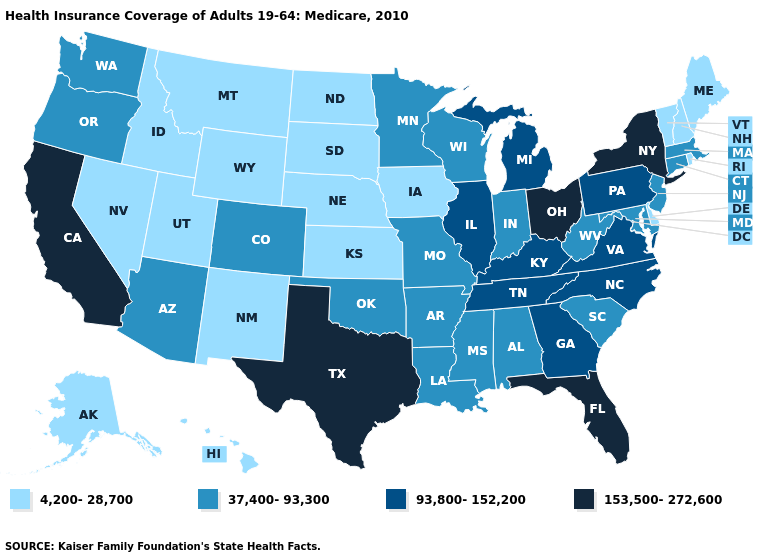Does the map have missing data?
Write a very short answer. No. Does New York have a higher value than Florida?
Keep it brief. No. Does the map have missing data?
Keep it brief. No. What is the value of Arkansas?
Give a very brief answer. 37,400-93,300. What is the highest value in the USA?
Short answer required. 153,500-272,600. Does Idaho have the same value as Texas?
Concise answer only. No. What is the value of New Jersey?
Quick response, please. 37,400-93,300. Is the legend a continuous bar?
Keep it brief. No. What is the highest value in the MidWest ?
Keep it brief. 153,500-272,600. Does Florida have the same value as Ohio?
Quick response, please. Yes. Name the states that have a value in the range 153,500-272,600?
Short answer required. California, Florida, New York, Ohio, Texas. Is the legend a continuous bar?
Answer briefly. No. Does Washington have the same value as Alabama?
Answer briefly. Yes. Does South Carolina have a lower value than Ohio?
Be succinct. Yes. What is the value of Virginia?
Concise answer only. 93,800-152,200. 